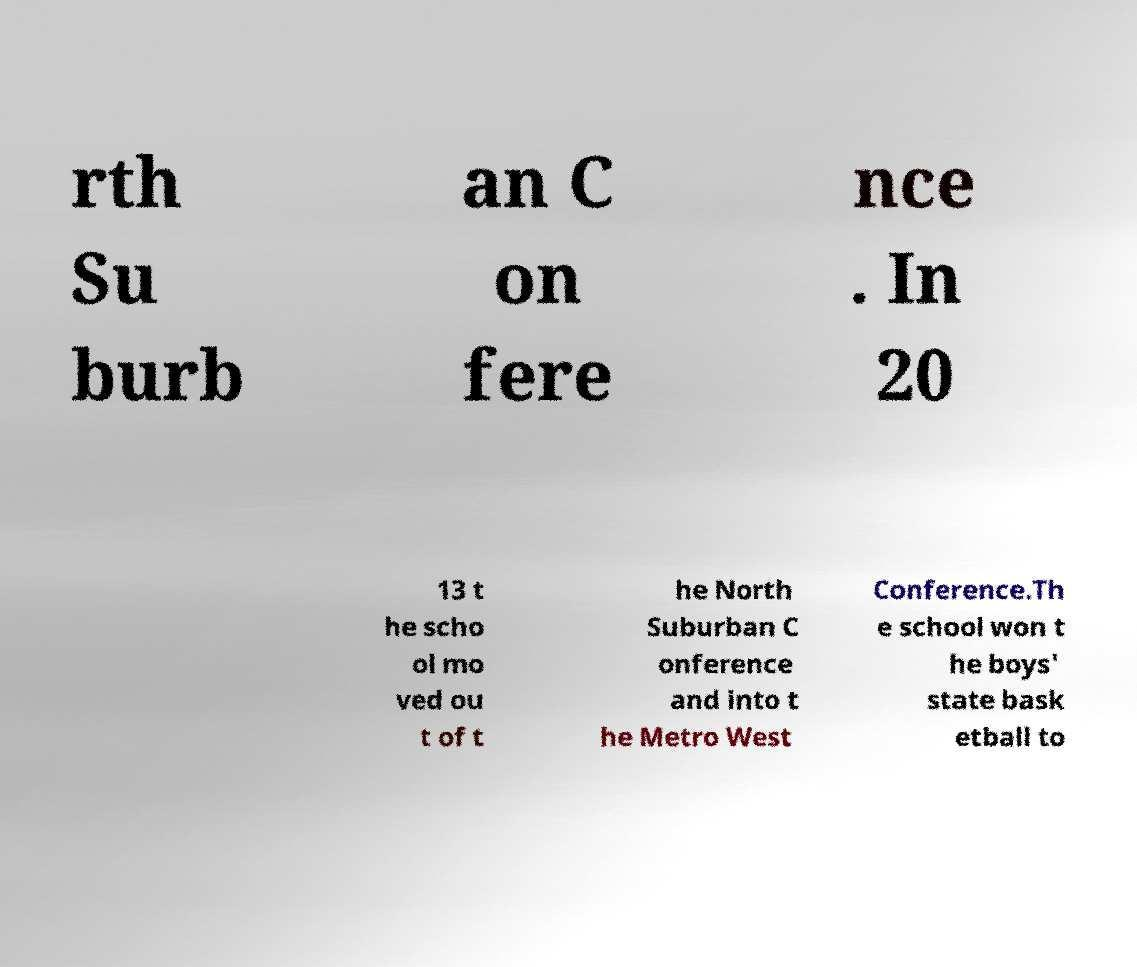For documentation purposes, I need the text within this image transcribed. Could you provide that? rth Su burb an C on fere nce . In 20 13 t he scho ol mo ved ou t of t he North Suburban C onference and into t he Metro West Conference.Th e school won t he boys' state bask etball to 